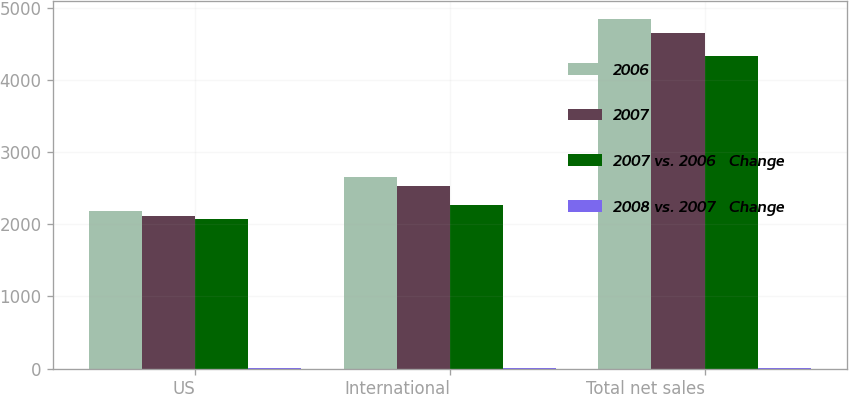Convert chart. <chart><loc_0><loc_0><loc_500><loc_500><stacked_bar_chart><ecel><fcel>US<fcel>International<fcel>Total net sales<nl><fcel>2006<fcel>2185.2<fcel>2658.3<fcel>4843.5<nl><fcel>2007<fcel>2118.2<fcel>2533<fcel>4651.2<nl><fcel>2007 vs. 2006   Change<fcel>2066.3<fcel>2261.6<fcel>4327.9<nl><fcel>2008 vs. 2007   Change<fcel>3<fcel>5<fcel>4<nl></chart> 